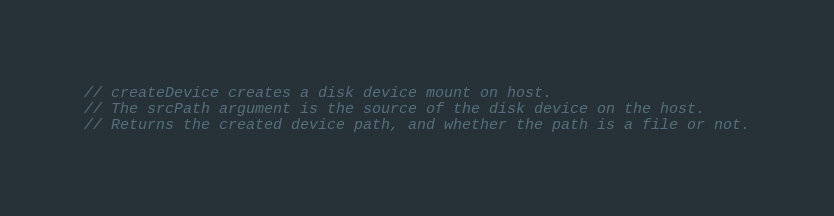<code> <loc_0><loc_0><loc_500><loc_500><_Go_>
// createDevice creates a disk device mount on host.
// The srcPath argument is the source of the disk device on the host.
// Returns the created device path, and whether the path is a file or not.</code> 